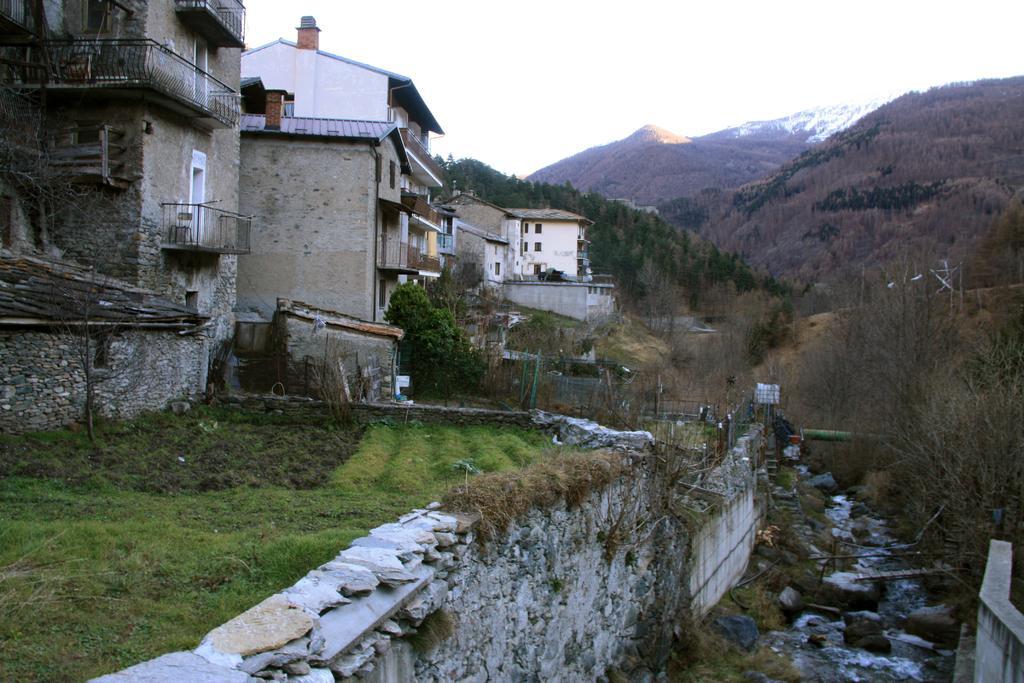In one or two sentences, can you explain what this image depicts? In this picture there are buildings on the left side of the image. On the right side of the image there are mountains and there are trees on the mountains. At the back there are trees. In the foreground there is a wall. At the top there is sky. At the bottom there is water and grass. 